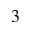<formula> <loc_0><loc_0><loc_500><loc_500>^ { 3 }</formula> 